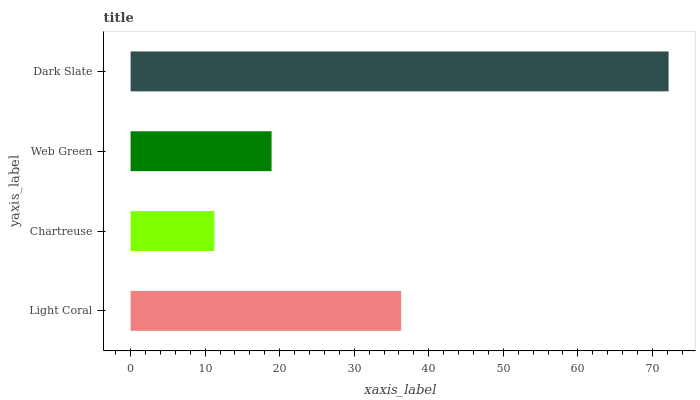Is Chartreuse the minimum?
Answer yes or no. Yes. Is Dark Slate the maximum?
Answer yes or no. Yes. Is Web Green the minimum?
Answer yes or no. No. Is Web Green the maximum?
Answer yes or no. No. Is Web Green greater than Chartreuse?
Answer yes or no. Yes. Is Chartreuse less than Web Green?
Answer yes or no. Yes. Is Chartreuse greater than Web Green?
Answer yes or no. No. Is Web Green less than Chartreuse?
Answer yes or no. No. Is Light Coral the high median?
Answer yes or no. Yes. Is Web Green the low median?
Answer yes or no. Yes. Is Web Green the high median?
Answer yes or no. No. Is Dark Slate the low median?
Answer yes or no. No. 